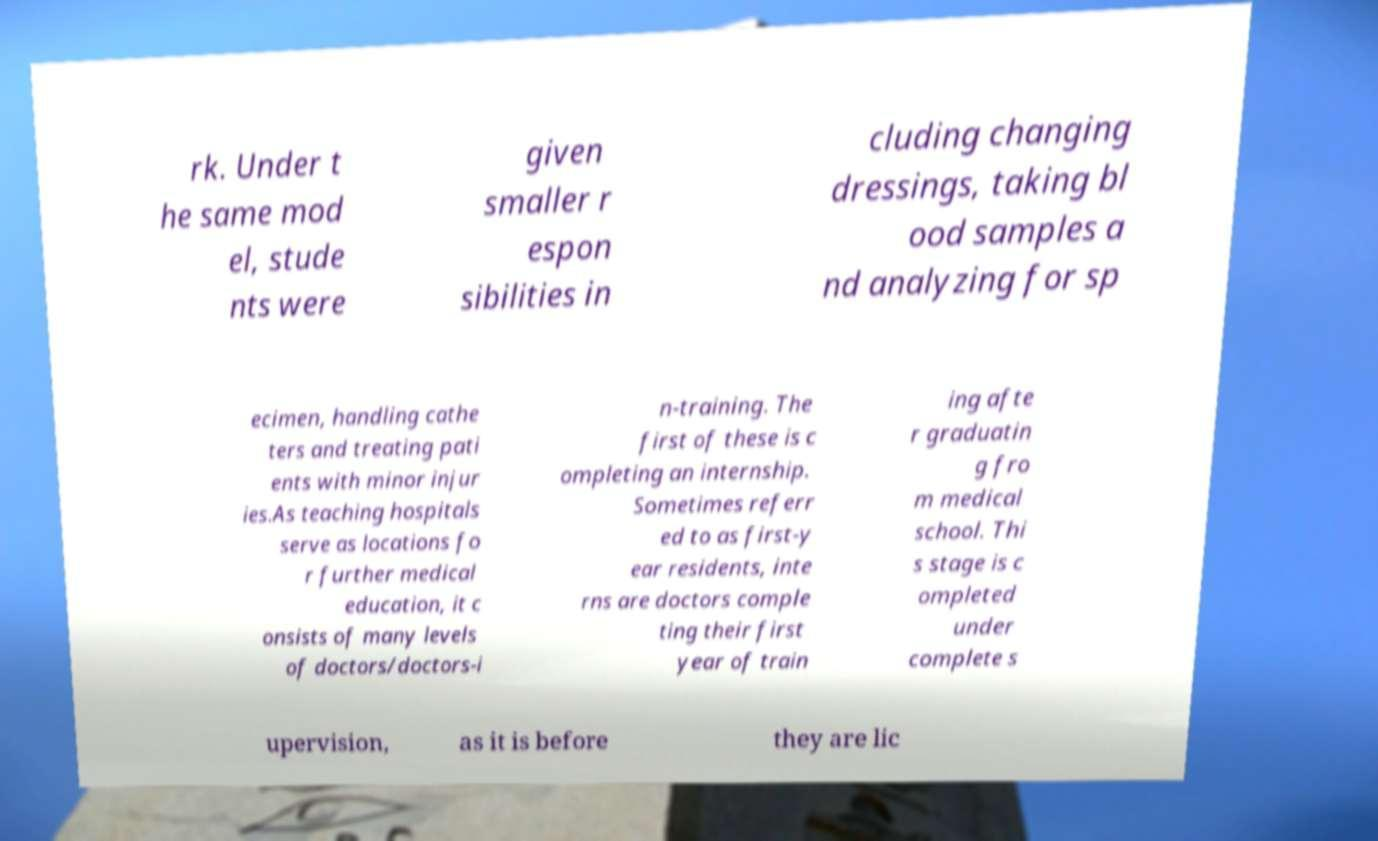There's text embedded in this image that I need extracted. Can you transcribe it verbatim? rk. Under t he same mod el, stude nts were given smaller r espon sibilities in cluding changing dressings, taking bl ood samples a nd analyzing for sp ecimen, handling cathe ters and treating pati ents with minor injur ies.As teaching hospitals serve as locations fo r further medical education, it c onsists of many levels of doctors/doctors-i n-training. The first of these is c ompleting an internship. Sometimes referr ed to as first-y ear residents, inte rns are doctors comple ting their first year of train ing afte r graduatin g fro m medical school. Thi s stage is c ompleted under complete s upervision, as it is before they are lic 